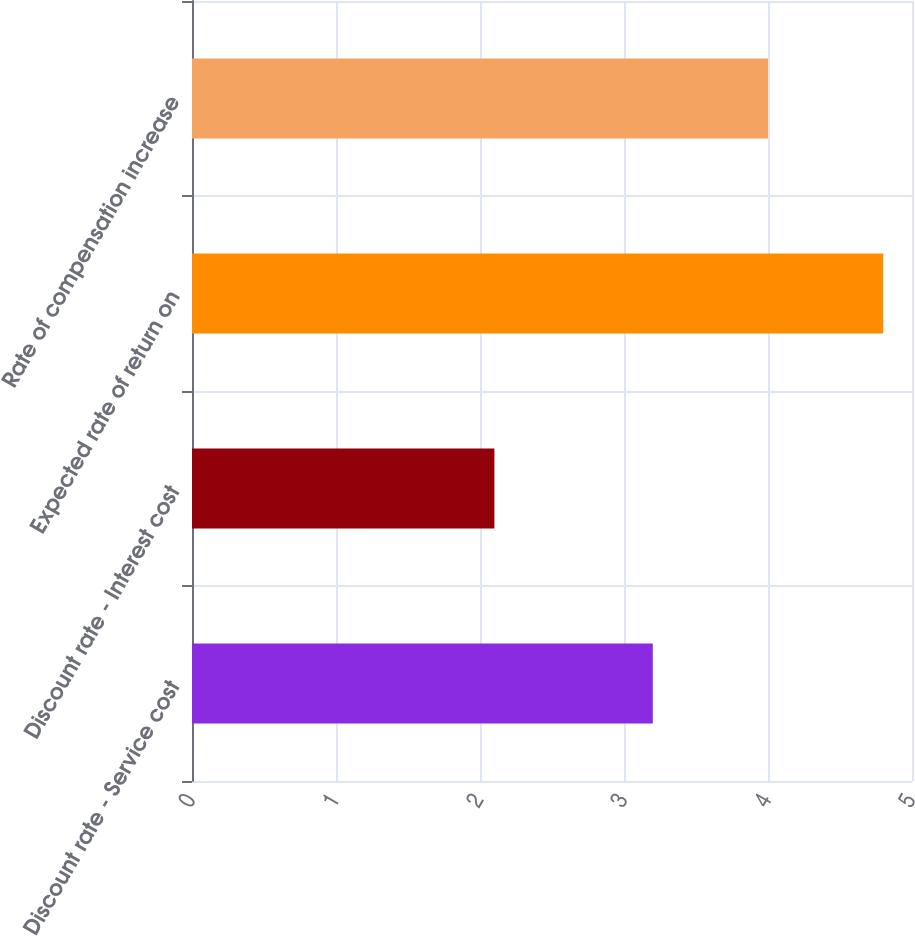Convert chart to OTSL. <chart><loc_0><loc_0><loc_500><loc_500><bar_chart><fcel>Discount rate - Service cost<fcel>Discount rate - Interest cost<fcel>Expected rate of return on<fcel>Rate of compensation increase<nl><fcel>3.2<fcel>2.1<fcel>4.8<fcel>4<nl></chart> 